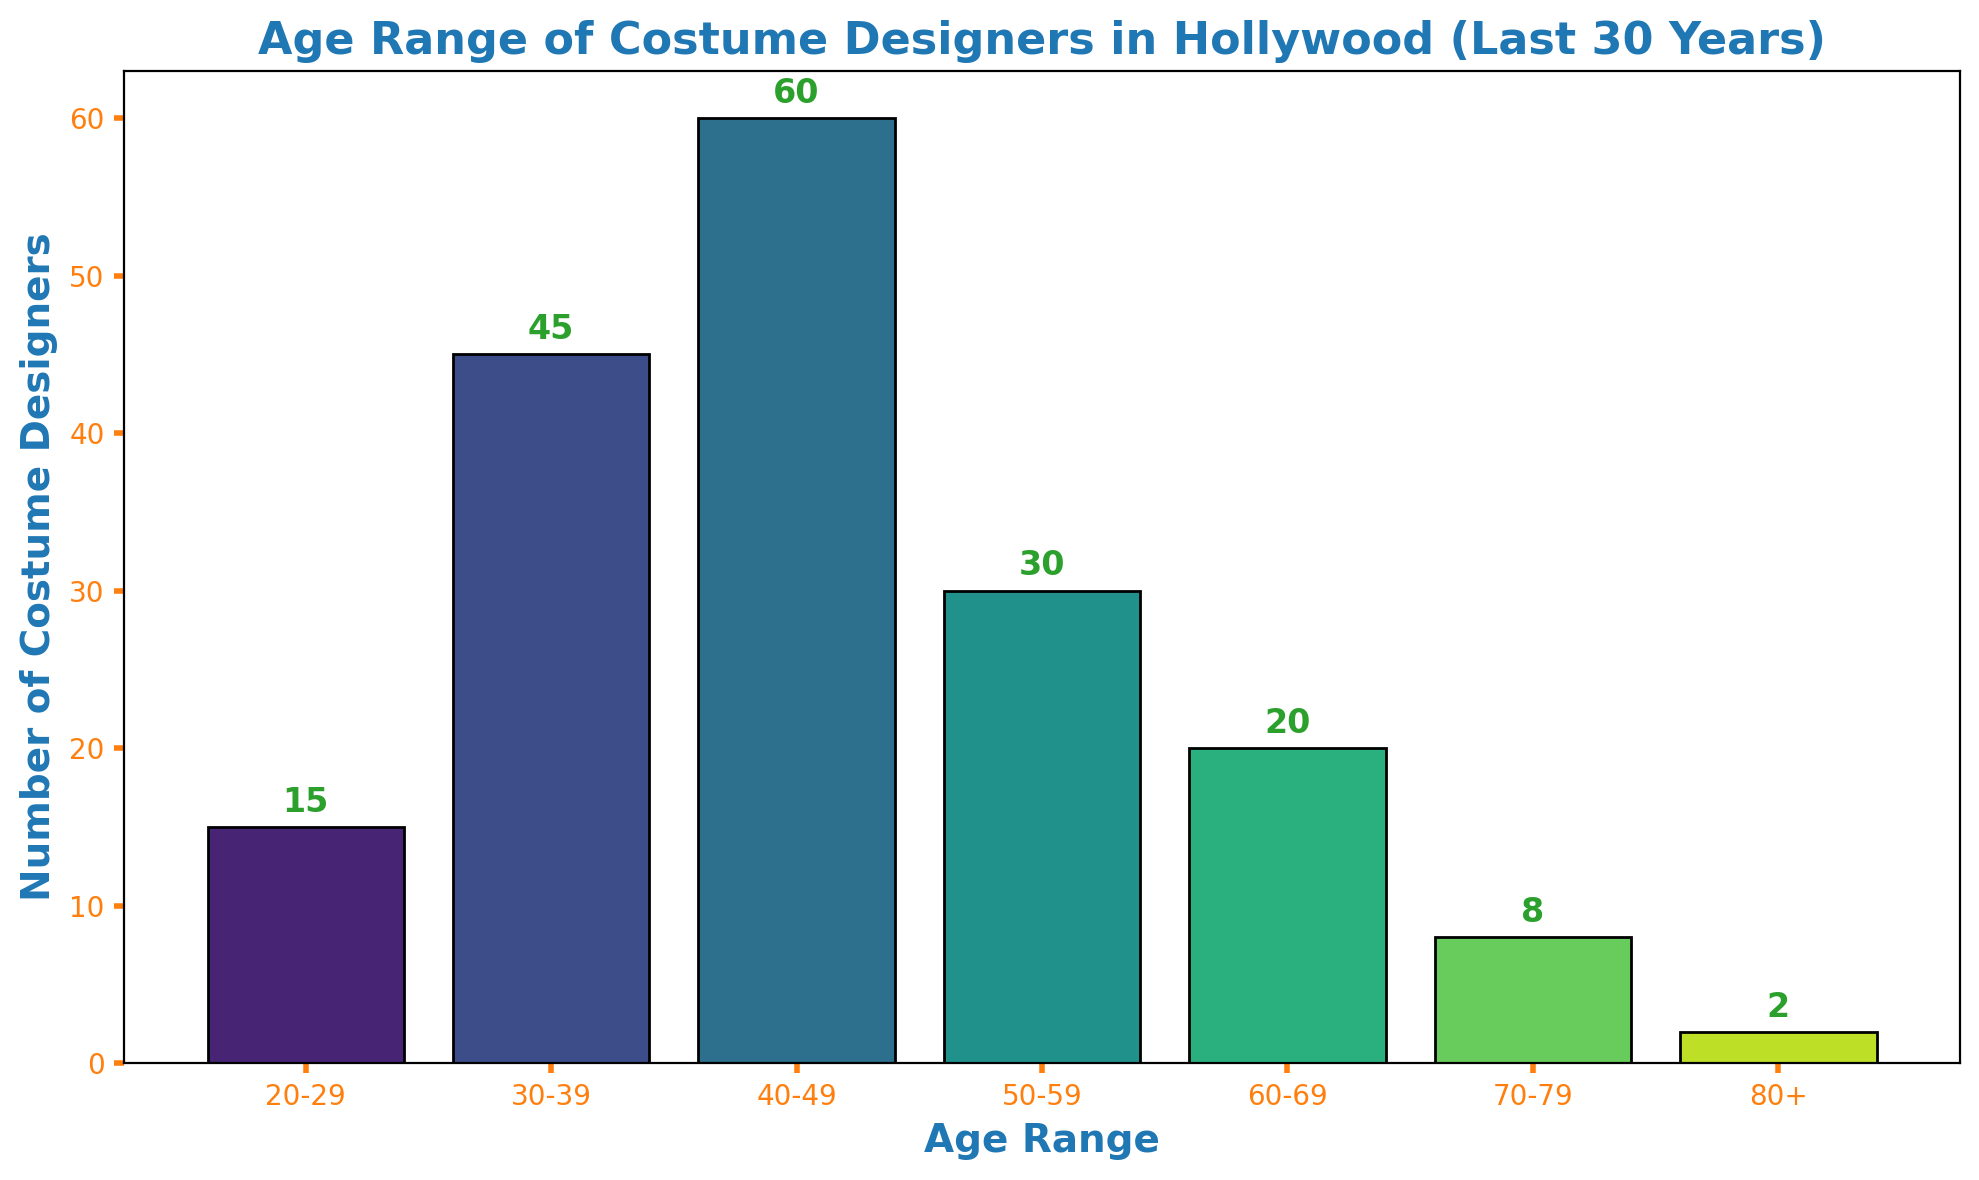What age range has the highest number of costume designers? The highest bar in the histogram represents the age range with the most costume designers. By observing, the bar for the 40-49 age range is the tallest.
Answer: 40-49 How many costume designers are aged 60 or older? To find this, sum the number of costume designers in the 60-69, 70-79, and 80+ age ranges. The values are 20, 8, and 2 respectively. So, 20 + 8 + 2 = 30.
Answer: 30 Comparing the 30-39 and 50-59 age ranges, which has more costume designers and by how much? Subtract the number of costume designers aged 50-59 from those aged 30-39. The number for 30-39 is 45, and for 50-59 is 30. So, 45 - 30 = 15.
Answer: 30-39 has 15 more What is the combined total of costume designers in the age ranges 20-29 and 50-59? Add the number of costume designers in the 20-29 age range (15) to those in the 50-59 range (30). So, 15 + 30 = 45.
Answer: 45 Which age range has the smallest number of costume designers? The smallest bar on the histogram represents the age range with the least number of costume designers. The bar for the 80+ age range is the shortest.
Answer: 80+ What is the difference in the number of costume designers between the 40-49 and 20-29 age ranges? Subtract the number of costume designers aged 20-29 from those aged 40-49. The values are 60 and 15 respectively. So, 60 - 15 = 45.
Answer: 45 What is the average number of costume designers for all age ranges? Sum the number of costume designers across all age ranges and divide by the total number of age ranges. The total is 15 + 45 + 60 + 30 + 20 + 8 + 2 = 180. There are 7 age ranges, so the average is 180 / 7 ≈ 25.7.
Answer: ≈ 25.7 What percentage of the total costume designers are in the 40-49 age range? Divide the number of costume designers aged 40-49 by the total number of costume designers and multiply by 100. So, (60 / 180) * 100 ≈ 33.33%.
Answer: ≈ 33.33% Are there more costume designers in the 30-39 age range or in the 50-59 and 20-29 age ranges combined? Sum the number of costume designers in the 50-59 and 20-29 age ranges and compare it with the 30-39 range. 50-59 + 20-29 = 30 + 15 = 45, which is equal to the 30-39 range.
Answer: They are equal 